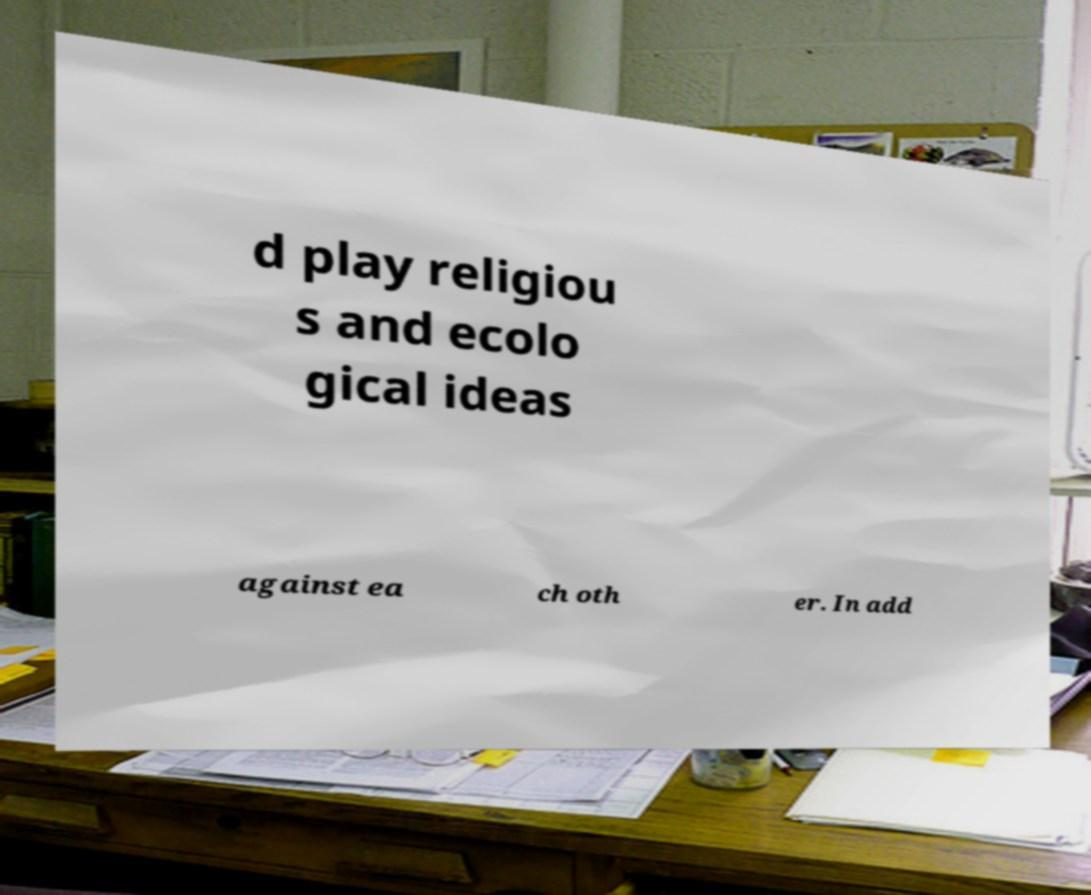For documentation purposes, I need the text within this image transcribed. Could you provide that? d play religiou s and ecolo gical ideas against ea ch oth er. In add 